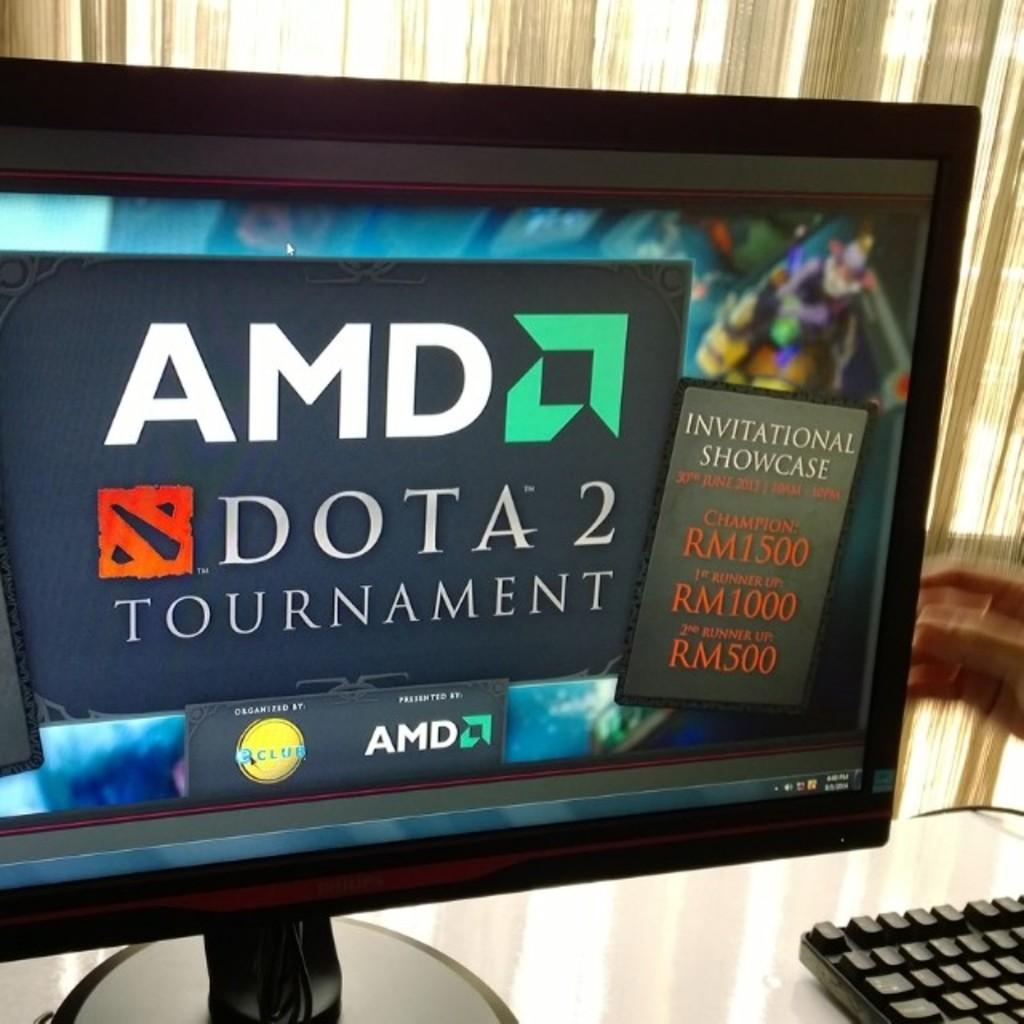What is the main object on the table in the image? There is a keyboard on the table in the image. What is located in front of the keyboard? There is a computer screen in the image. What can be seen in the background of the image? There is a window with cloth in the background of the image. What is displayed on the computer screen? There are posters visible on the computer screen. What type of feast is being prepared on the table in the image? There is no feast being prepared on the table in the image; it contains a keyboard and a computer screen. 